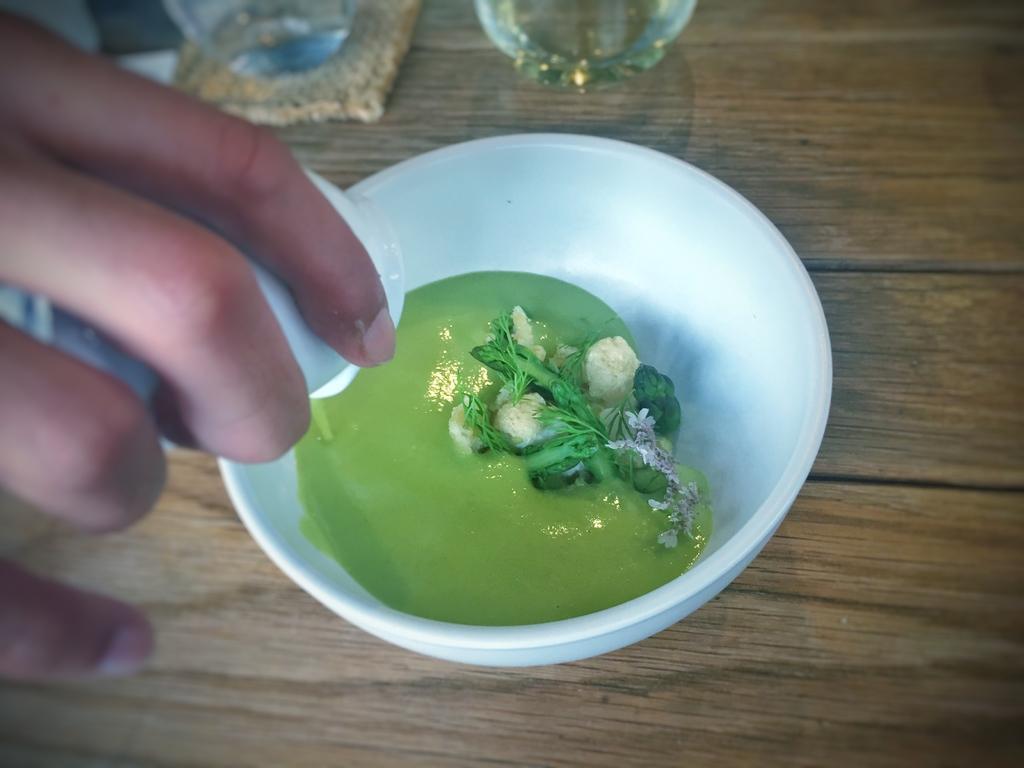In one or two sentences, can you explain what this image depicts? In this image we can see a food item in a bowl on the wooden surface. To the left side of the image there is a person's hand. 